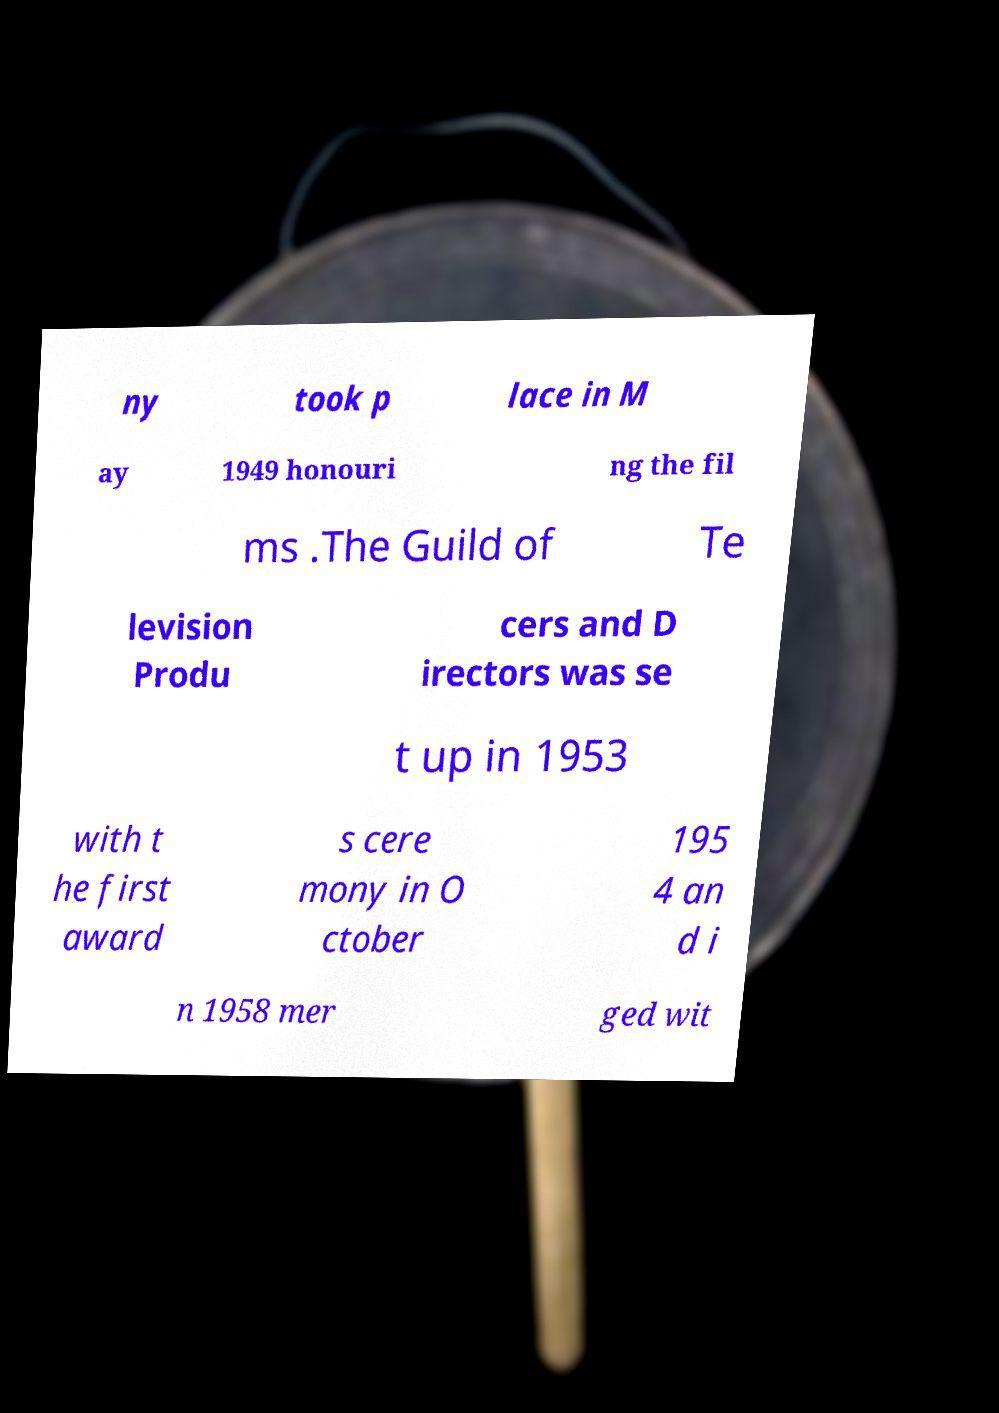Could you extract and type out the text from this image? ny took p lace in M ay 1949 honouri ng the fil ms .The Guild of Te levision Produ cers and D irectors was se t up in 1953 with t he first award s cere mony in O ctober 195 4 an d i n 1958 mer ged wit 